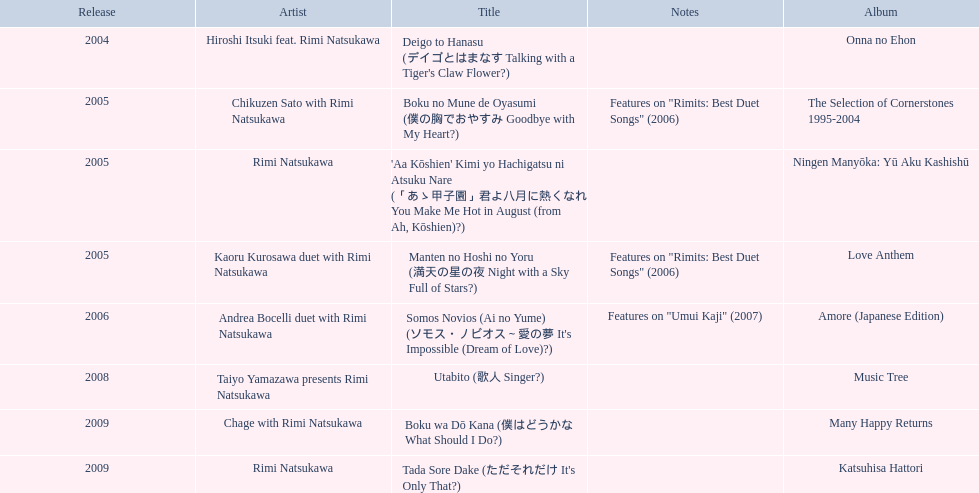What has been the last song this artist has made an other appearance on? Tada Sore Dake. 